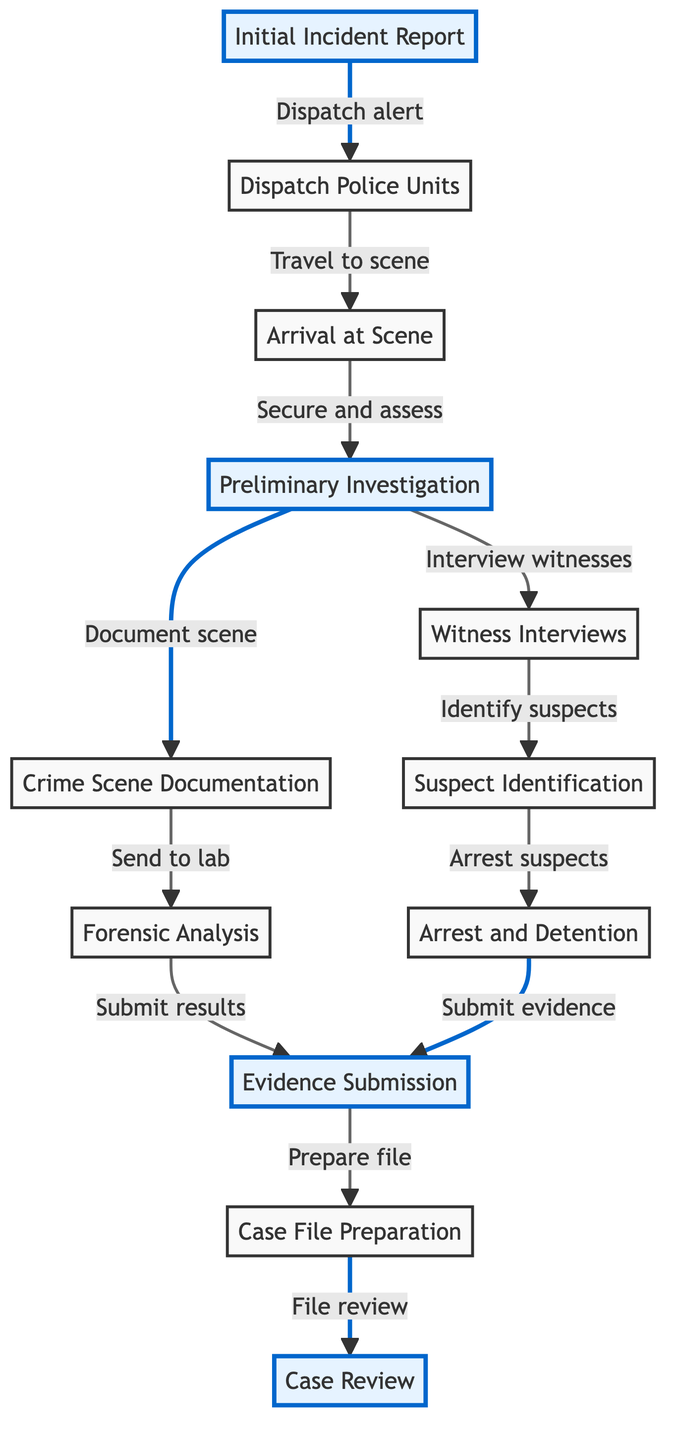What is the first step in the timeline? The diagram starts with the first node labeled "Initial Incident Report," indicating that this is the beginning of the timeline for the crime scene incident.
Answer: Initial Incident Report How many nodes are there in total? By counting each individual step represented in the diagram, we find there are twelve distinct nodes detailing the timeline steps.
Answer: Twelve Which step follows the "Preliminary Investigation"? The arrow connects "Preliminary Investigation" directly to "Crime Scene Documentation," indicating that documentation is the next step in the process after preliminary investigation.
Answer: Crime Scene Documentation What action takes place after "Forensic Analysis"? After "Forensic Analysis," the results are submitted, leading to the node labeled "Evidence Submission," which shows the outcome of the analysis process.
Answer: Evidence Submission Which step indicates the preparation of the case file? In the diagram, "Case File Preparation" logically follows "Evidence Submission," showing it as the step where the case file is compiled with the gathered evidence and information.
Answer: Case File Preparation How many highlights are present in the diagram? By reviewing the diagram, we note there are five highlighted steps. These are moments of particular importance in the overall timeline structure, indicating critical actions.
Answer: Five What is the final step in the timeline? The last node in the flowchart designated at the end of the crime scene timeline is "Case Review," summarizing the culmination of all previous work and analysis.
Answer: Case Review Identify the relationship between "Suspect Identification" and "Arrest and Detention." The diagram shows that "Suspect Identification" directly leads to "Arrest and Detention," indicating that identifying a suspect is a prerequisite for making an arrest.
Answer: Directly leads to What step does the Dispatch Police Units require before action? The arrow drawn from "Initial Incident Report" to "Dispatch Police Units" shows that an incident report alerts dispatch, making it the required precursor to dispatching units.
Answer: Initial Incident Report 